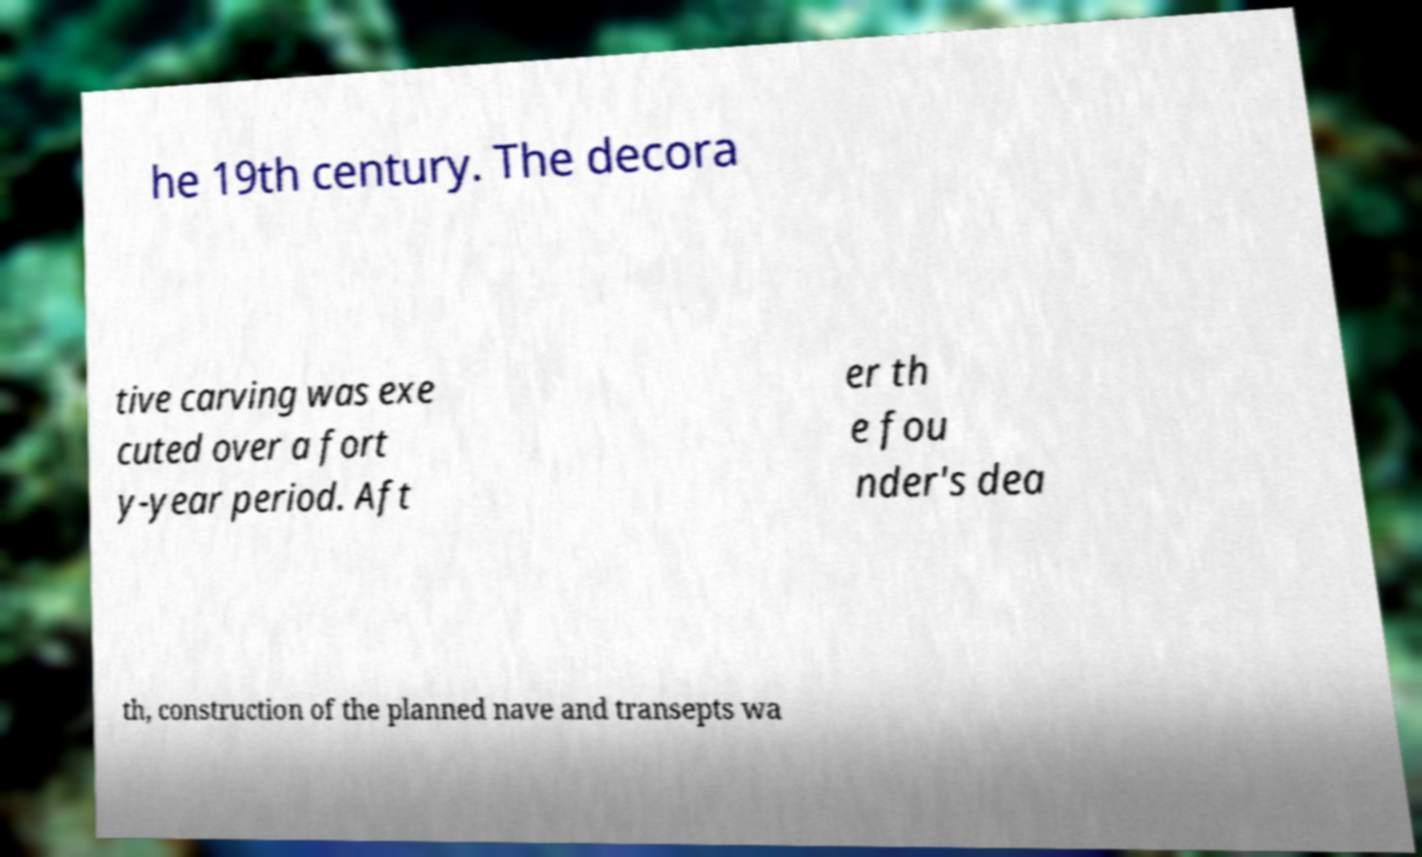What messages or text are displayed in this image? I need them in a readable, typed format. he 19th century. The decora tive carving was exe cuted over a fort y-year period. Aft er th e fou nder's dea th, construction of the planned nave and transepts wa 